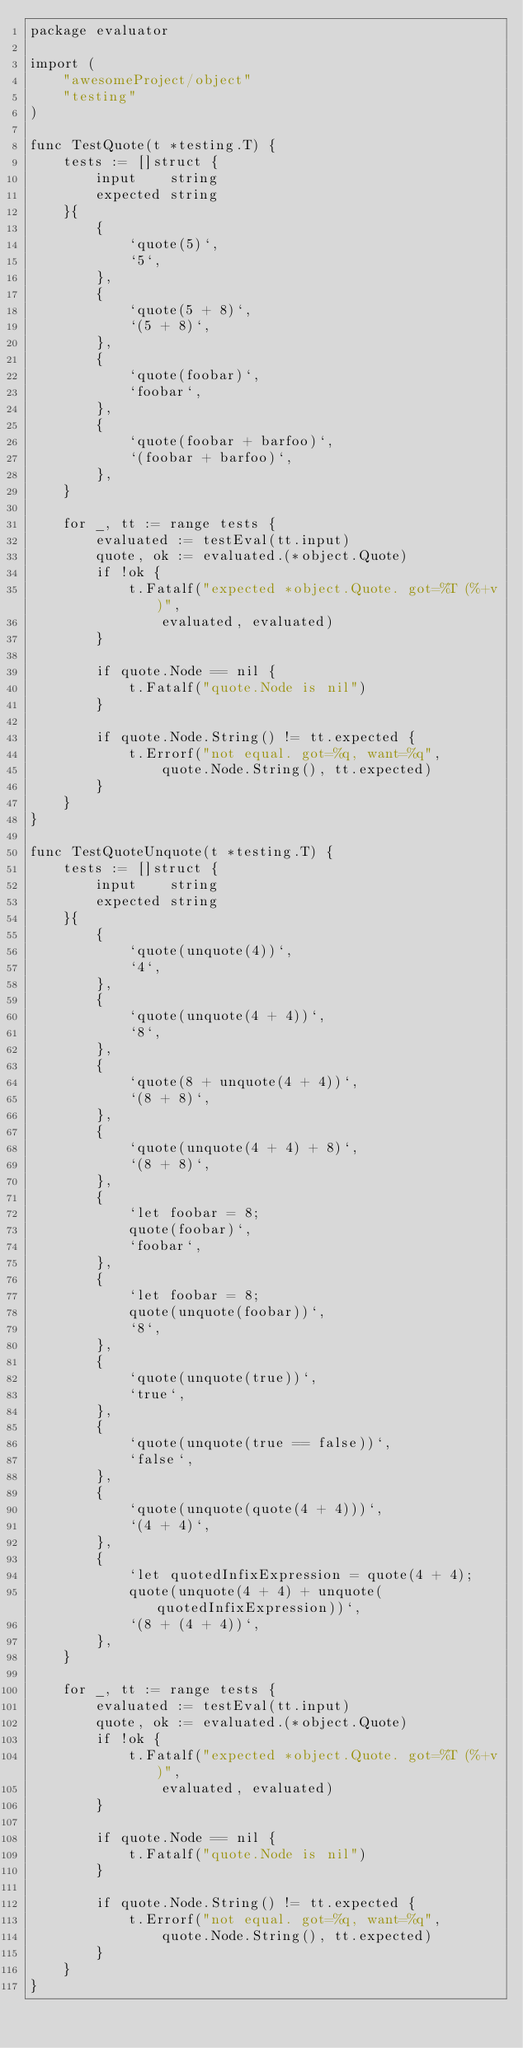<code> <loc_0><loc_0><loc_500><loc_500><_Go_>package evaluator

import (
	"awesomeProject/object"
	"testing"
)

func TestQuote(t *testing.T) {
	tests := []struct {
		input    string
		expected string
	}{
		{
			`quote(5)`,
			`5`,
		},
		{
			`quote(5 + 8)`,
			`(5 + 8)`,
		},
		{
			`quote(foobar)`,
			`foobar`,
		},
		{
			`quote(foobar + barfoo)`,
			`(foobar + barfoo)`,
		},
	}

	for _, tt := range tests {
		evaluated := testEval(tt.input)
		quote, ok := evaluated.(*object.Quote)
		if !ok {
			t.Fatalf("expected *object.Quote. got=%T (%+v)",
				evaluated, evaluated)
		}

		if quote.Node == nil {
			t.Fatalf("quote.Node is nil")
		}

		if quote.Node.String() != tt.expected {
			t.Errorf("not equal. got=%q, want=%q",
				quote.Node.String(), tt.expected)
		}
	}
}

func TestQuoteUnquote(t *testing.T) {
	tests := []struct {
		input    string
		expected string
	}{
		{
			`quote(unquote(4))`,
			`4`,
		},
		{
			`quote(unquote(4 + 4))`,
			`8`,
		},
		{
			`quote(8 + unquote(4 + 4))`,
			`(8 + 8)`,
		},
		{
			`quote(unquote(4 + 4) + 8)`,
			`(8 + 8)`,
		},
		{
			`let foobar = 8;
            quote(foobar)`,
			`foobar`,
		},
		{
			`let foobar = 8;
            quote(unquote(foobar))`,
			`8`,
		},
		{
			`quote(unquote(true))`,
			`true`,
		},
		{
			`quote(unquote(true == false))`,
			`false`,
		},
		{
			`quote(unquote(quote(4 + 4)))`,
			`(4 + 4)`,
		},
		{
			`let quotedInfixExpression = quote(4 + 4);
            quote(unquote(4 + 4) + unquote(quotedInfixExpression))`,
			`(8 + (4 + 4))`,
		},
	}

	for _, tt := range tests {
		evaluated := testEval(tt.input)
		quote, ok := evaluated.(*object.Quote)
		if !ok {
			t.Fatalf("expected *object.Quote. got=%T (%+v)",
				evaluated, evaluated)
		}

		if quote.Node == nil {
			t.Fatalf("quote.Node is nil")
		}

		if quote.Node.String() != tt.expected {
			t.Errorf("not equal. got=%q, want=%q",
				quote.Node.String(), tt.expected)
		}
	}
}
</code> 